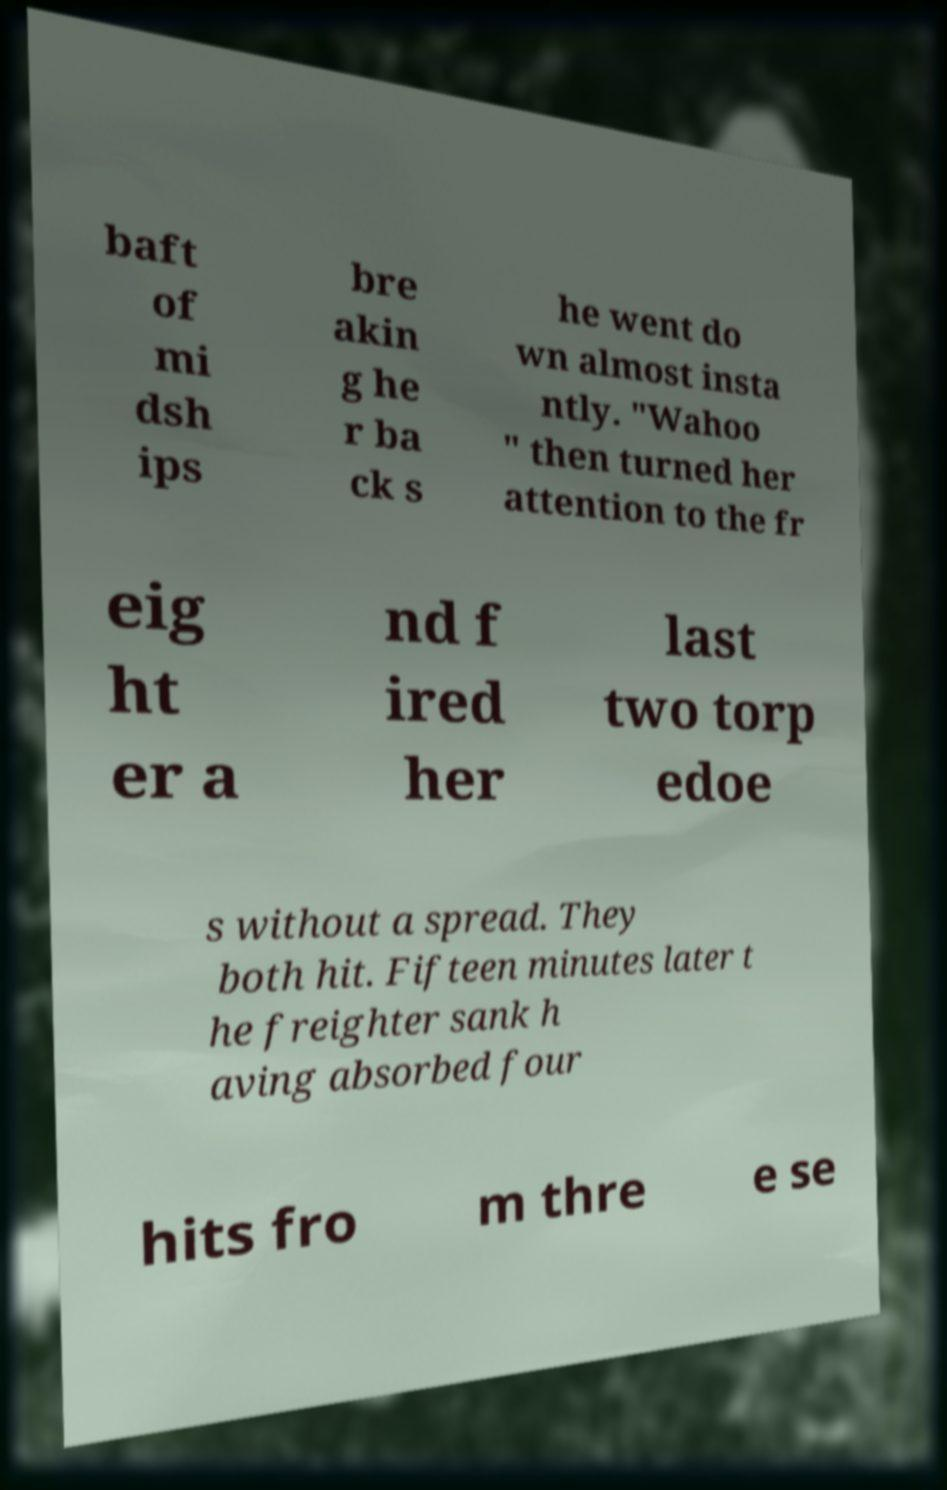Could you assist in decoding the text presented in this image and type it out clearly? baft of mi dsh ips bre akin g he r ba ck s he went do wn almost insta ntly. "Wahoo " then turned her attention to the fr eig ht er a nd f ired her last two torp edoe s without a spread. They both hit. Fifteen minutes later t he freighter sank h aving absorbed four hits fro m thre e se 